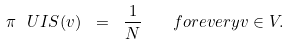Convert formula to latex. <formula><loc_0><loc_0><loc_500><loc_500>\pi ^ { \ } U I S ( v ) \ = \ \frac { 1 } { N } \quad f o r e v e r y v \in V .</formula> 